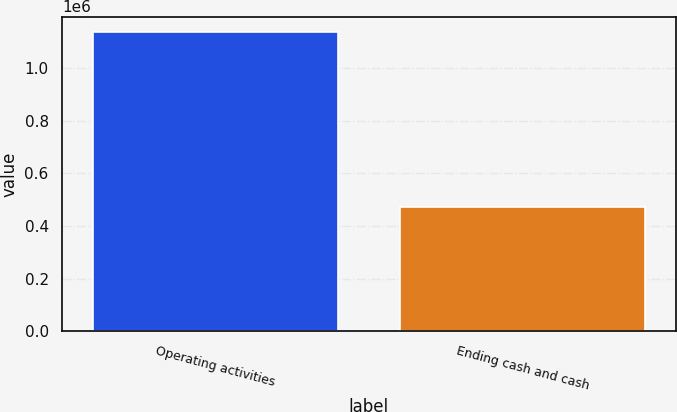<chart> <loc_0><loc_0><loc_500><loc_500><bar_chart><fcel>Operating activities<fcel>Ending cash and cash<nl><fcel>1.13867e+06<fcel>473726<nl></chart> 